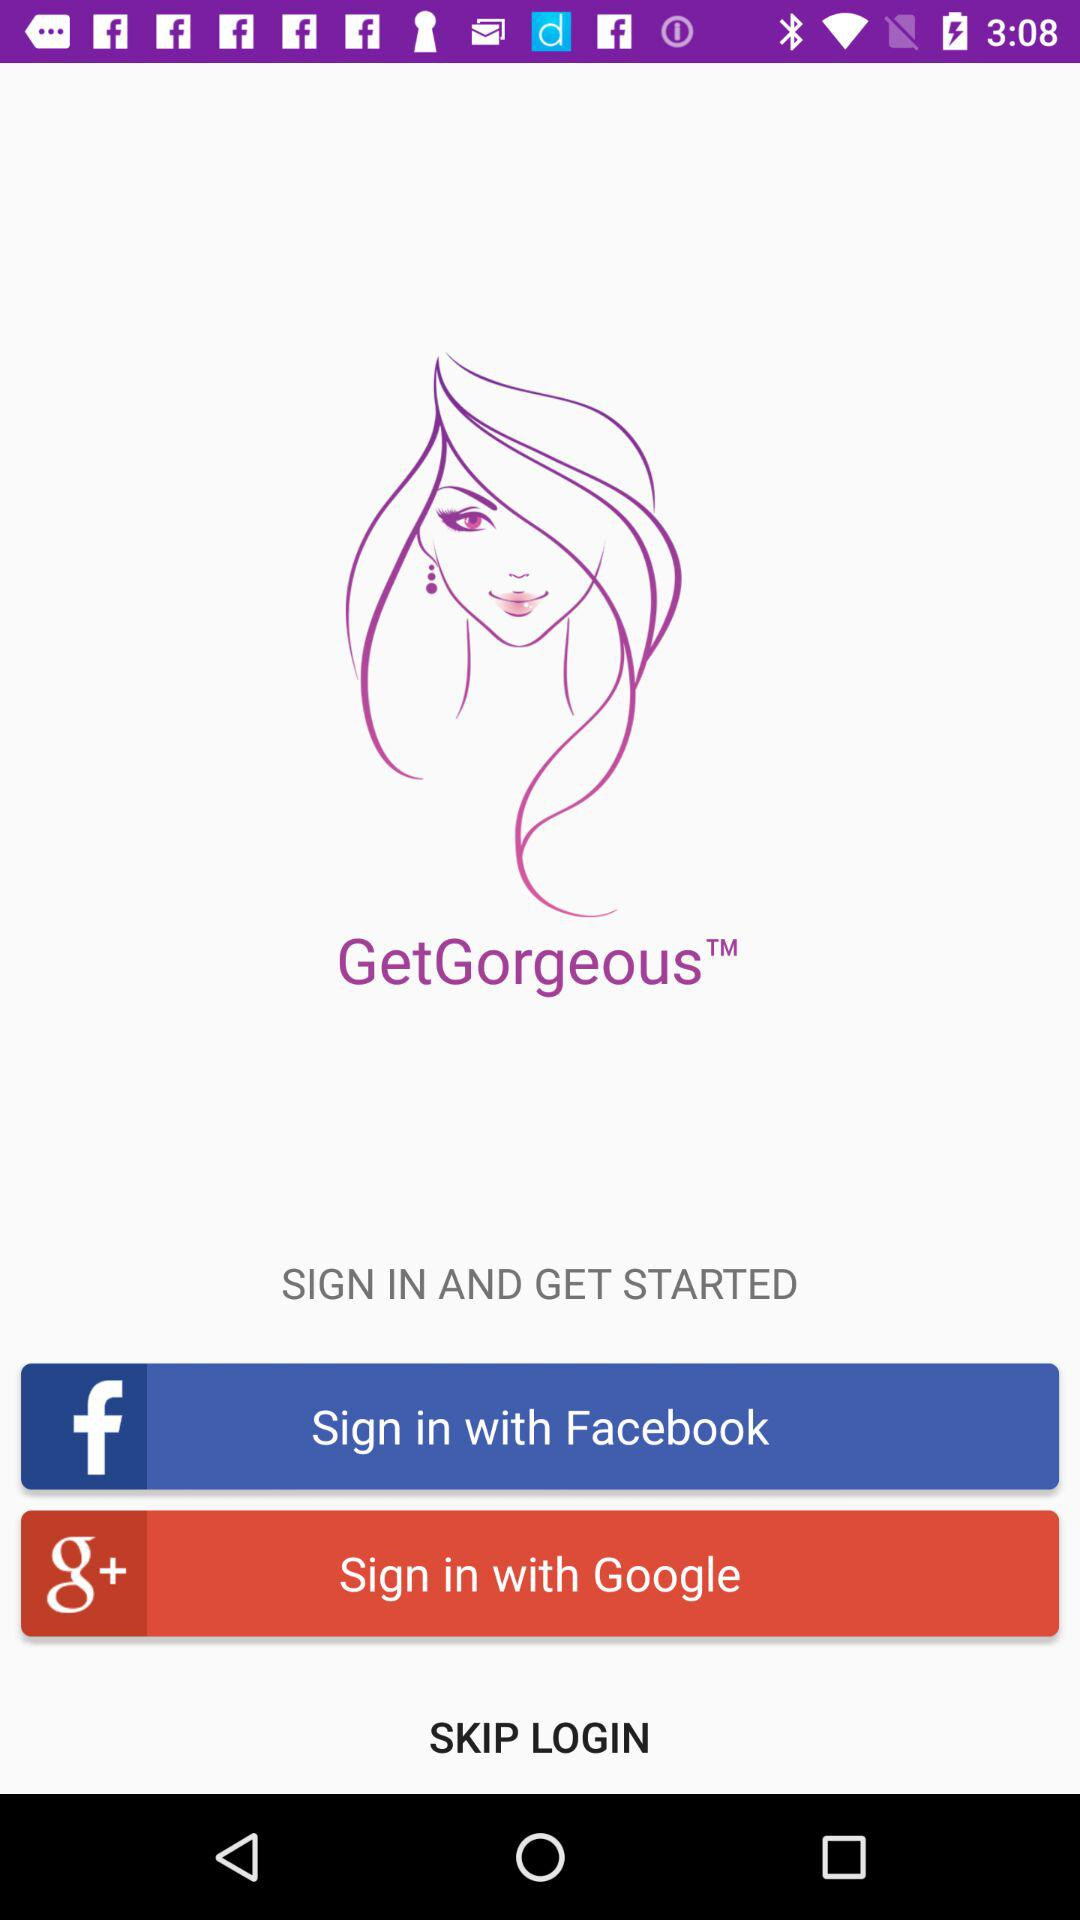Through what application can we sign in with? You can sign in with "Sign in with Facebook" and "Sign in with Google". 